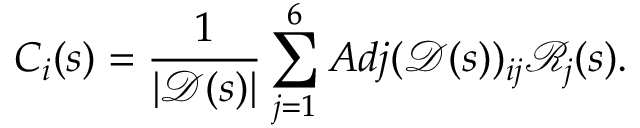<formula> <loc_0><loc_0><loc_500><loc_500>C _ { i } ( s ) = \frac { 1 } { | \ m a t h s c r { D } ( s ) | } \sum _ { j = 1 } ^ { 6 } A d j ( \ m a t h s c r { D } ( s ) ) _ { i j } \ m a t h s c r { R } _ { j } ( s ) .</formula> 